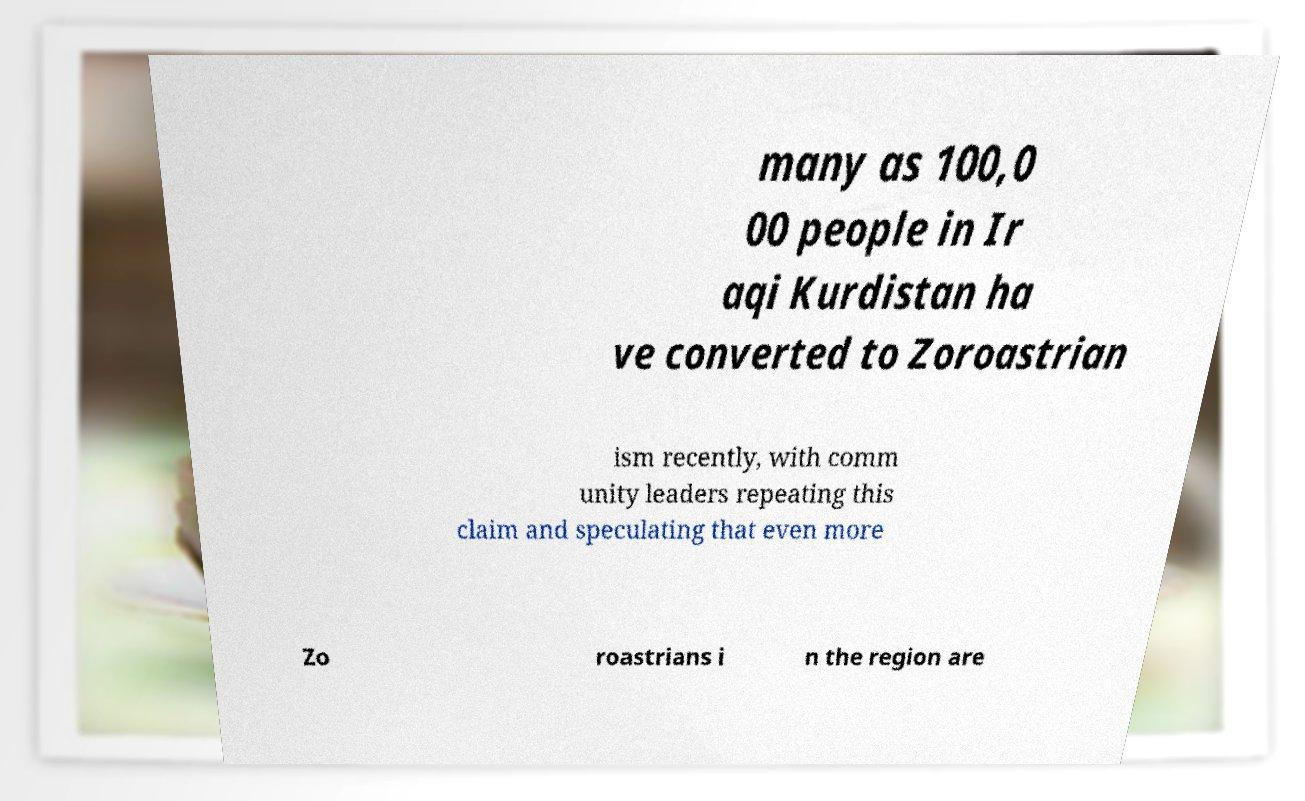Please read and relay the text visible in this image. What does it say? many as 100,0 00 people in Ir aqi Kurdistan ha ve converted to Zoroastrian ism recently, with comm unity leaders repeating this claim and speculating that even more Zo roastrians i n the region are 